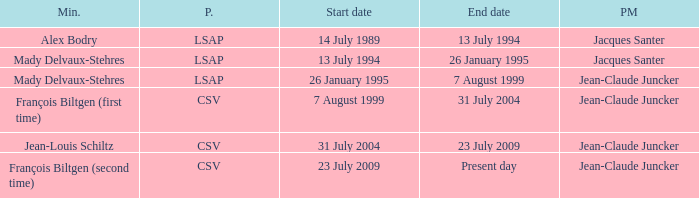What was the end date when Alex Bodry was the minister? 13 July 1994. 